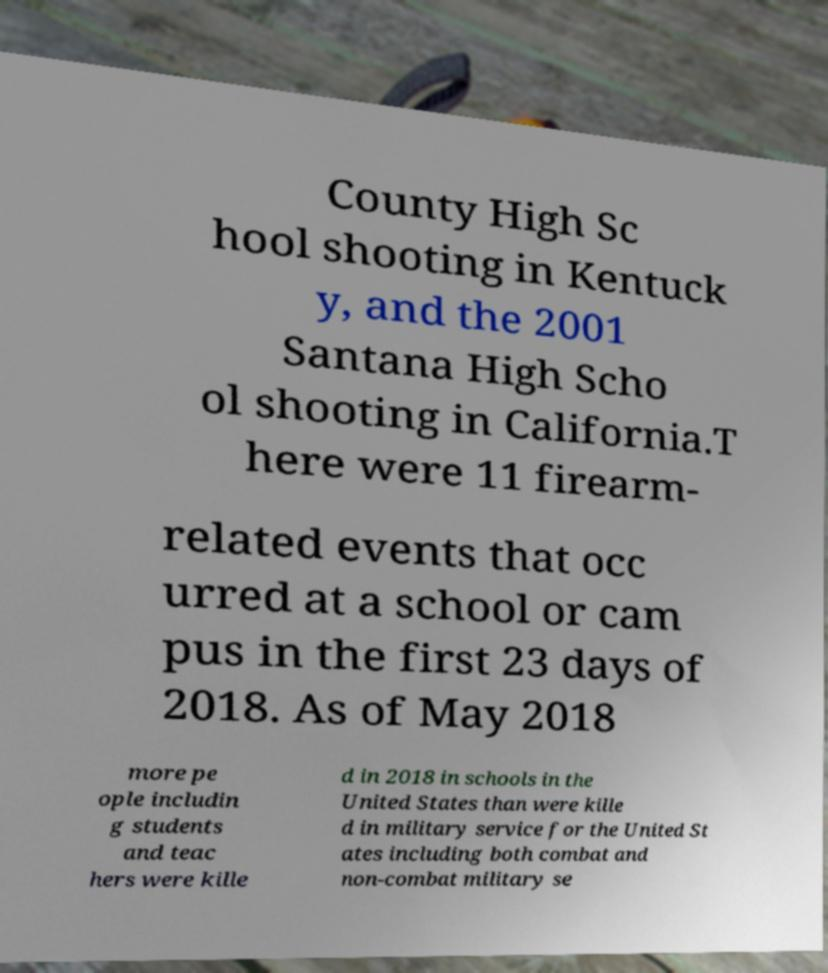Could you assist in decoding the text presented in this image and type it out clearly? County High Sc hool shooting in Kentuck y, and the 2001 Santana High Scho ol shooting in California.T here were 11 firearm- related events that occ urred at a school or cam pus in the first 23 days of 2018. As of May 2018 more pe ople includin g students and teac hers were kille d in 2018 in schools in the United States than were kille d in military service for the United St ates including both combat and non-combat military se 